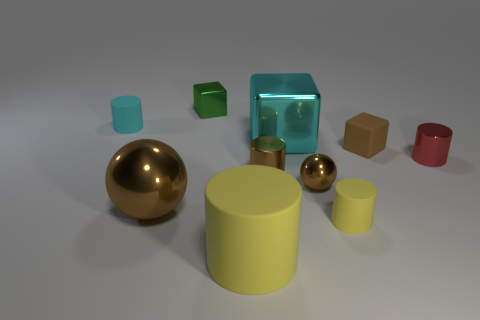Subtract all small rubber cylinders. How many cylinders are left? 3 Subtract all yellow cylinders. How many cylinders are left? 3 Subtract all balls. How many objects are left? 8 Subtract 3 cylinders. How many cylinders are left? 2 Subtract all brown balls. How many green cubes are left? 1 Add 5 tiny brown matte objects. How many tiny brown matte objects exist? 6 Subtract 0 purple spheres. How many objects are left? 10 Subtract all yellow blocks. Subtract all yellow cylinders. How many blocks are left? 3 Subtract all large cyan rubber spheres. Subtract all small brown rubber blocks. How many objects are left? 9 Add 4 large cyan metallic objects. How many large cyan metallic objects are left? 5 